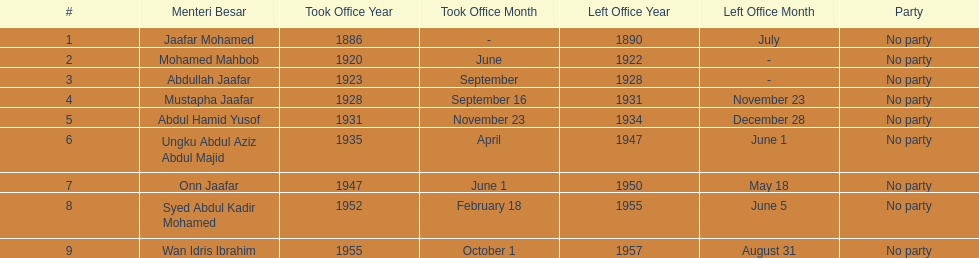Who is listed below onn jaafar? Syed Abdul Kadir Mohamed. 